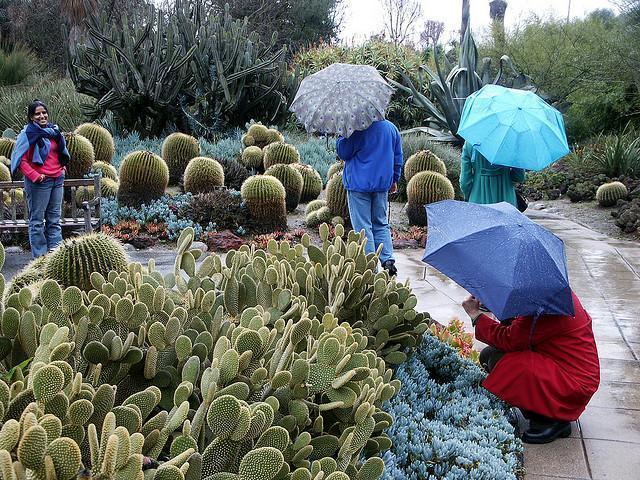These types of plants are good in what environment?
Pick the correct solution from the four options below to address the question.
Options: Snowy, desert, temperate, tropical. Desert. 